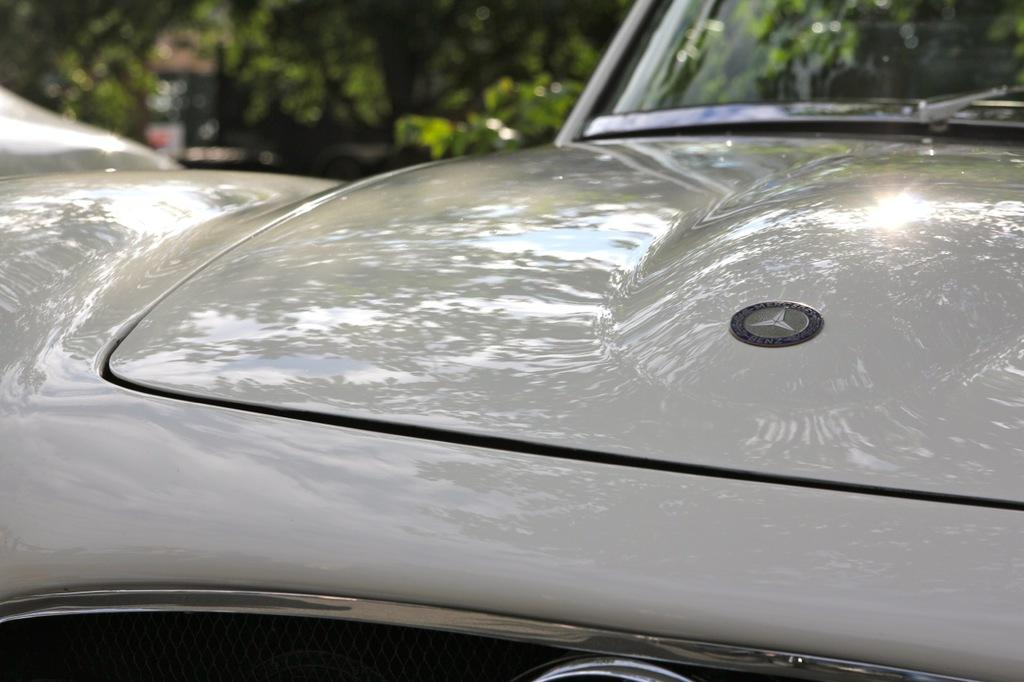What is the main subject of the image? There is a vehicle in the image. What color is the vehicle? The vehicle is gray in color. What can be seen in the background of the image? There are trees in the background of the image. What color are the trees? The trees are green in color. Is the vehicle in the image covered in snow? There is no snow present in the image, and the vehicle is not covered in snow. Can you see a bat flying in the image? There is no bat present in the image. 